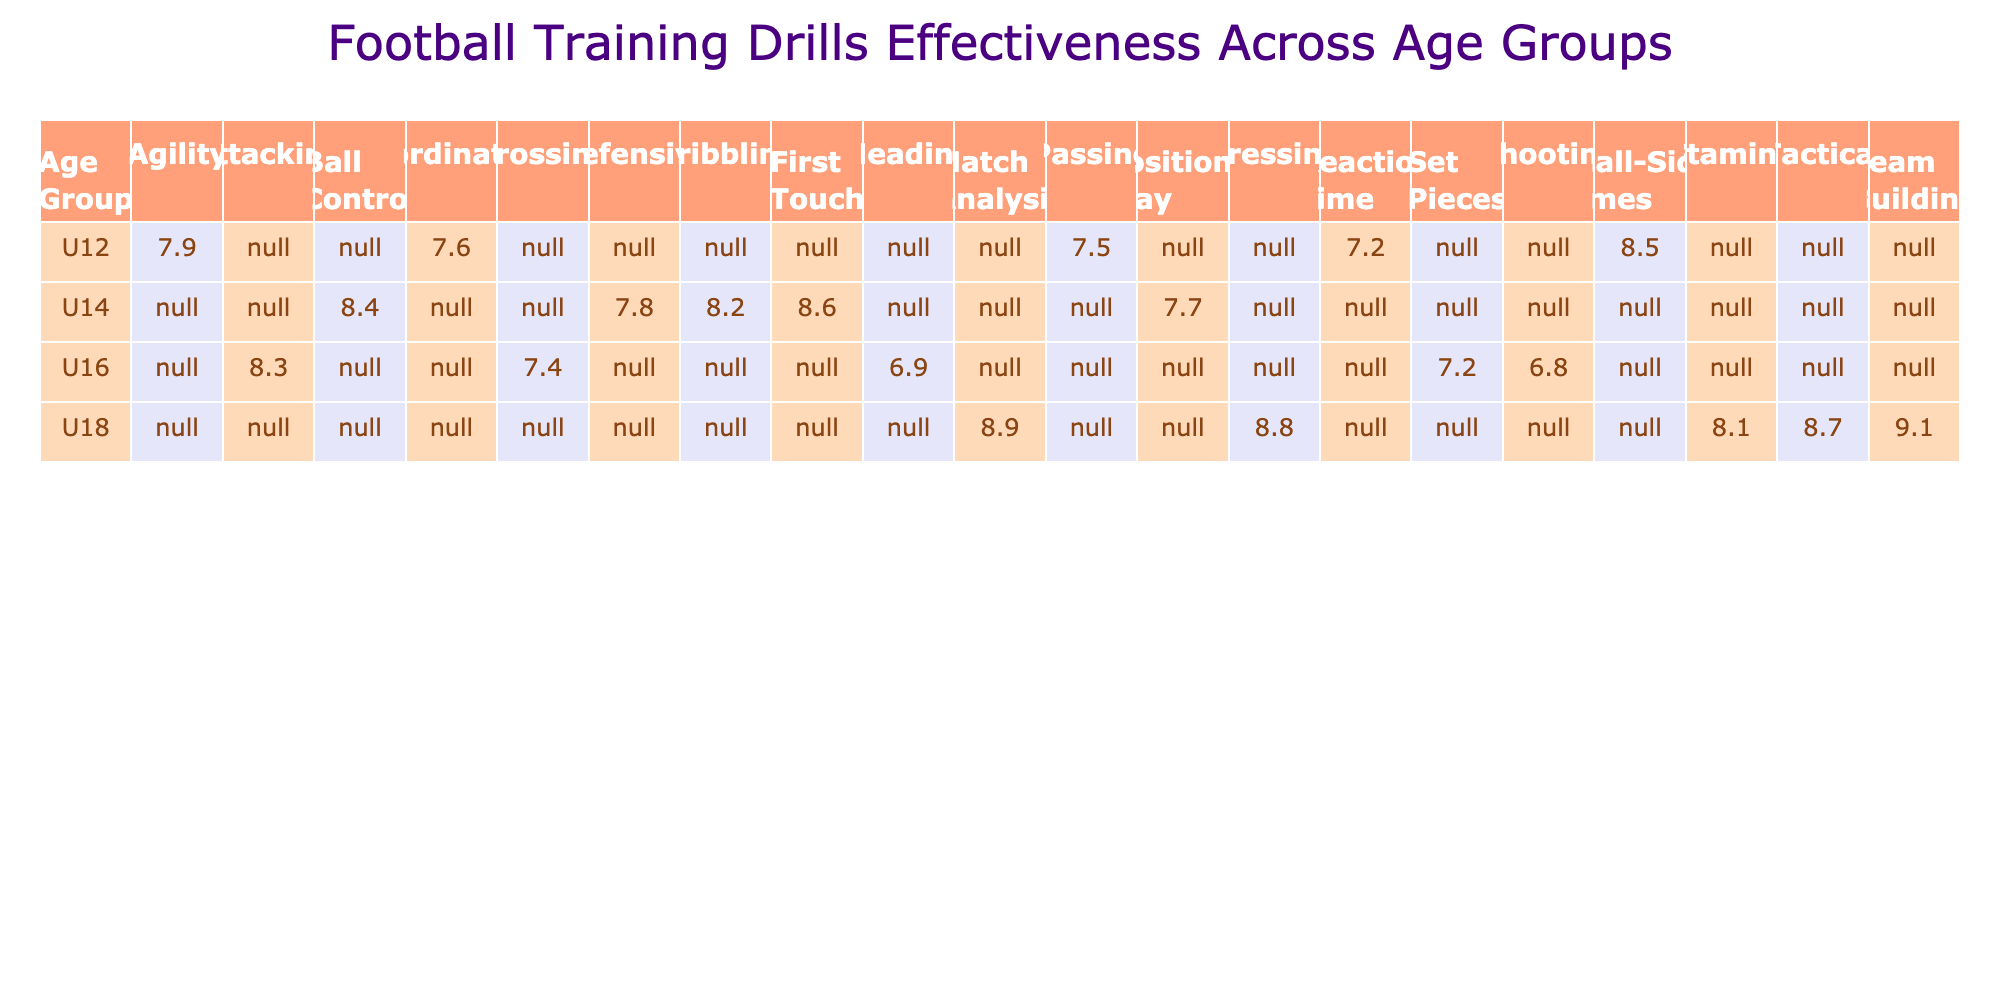What is the effectiveness score for the Tactical drill in the U18 age group? Referring to the table, the effectiveness score for the Tactical drill in the U18 age group is clearly listed. Under the U18 row and the Tactical column, the score is 8.7.
Answer: 8.7 Which drill has the highest effectiveness score in the U12 age group? In the U12 age group, we can look at all the effectiveness scores listed. The highest score is for the Small-Sided Games at 8.5.
Answer: Small-Sided Games What is the total effectiveness score for all drills in the U14 age group? To find the total effectiveness score, we need to sum the effectiveness scores for the U14 group: 8.2 + 8.4 + 7.8 + 8.6 + 7.7 = 40.7.
Answer: 40.7 Is the effectiveness score for the Shooting drill lower than 7.5 in the U16 age group? The effectiveness score for the Shooting drill in the U16 age group is 6.8, which is indeed lower than 7.5.
Answer: Yes Which age group shows the most variation in effectiveness scores across different drill types? Looking at the table, we can compare the effectiveness scores across age groups. The U18 age group has a range of scores (from 8.1 to 9.1) indicating some variance, while other groups have less range. Calculating differences confirms this variability in U18.
Answer: U18 What is the average effectiveness score for all drills in the U16 age group? In the U16 group, the scores are: 6.8, 7.2, 8.3, 6.9. Adding these gives 29.2. There are 4 scores, so the average is 29.2 / 4 = 7.3.
Answer: 7.3 Is it true that all drills in the U14 age group have an effectiveness score above 7.5? Looking at the U14 scores: 8.2, 8.4, 7.8, 8.6, and 7.7. Since 7.7 is above 7.5, the statement is true.
Answer: Yes What is the effectiveness score of the Match Analysis drill in the U18 age group compared to the lowest score in U12 age group drills? The effectiveness score of the Match Analysis drill is 8.9 and the lowest score in the U12 group is 7.2 (from Reaction Time). Comparing them shows that 8.9 is greater than 7.2, indicating a positive performance.
Answer: 8.9 is greater than 7.2 